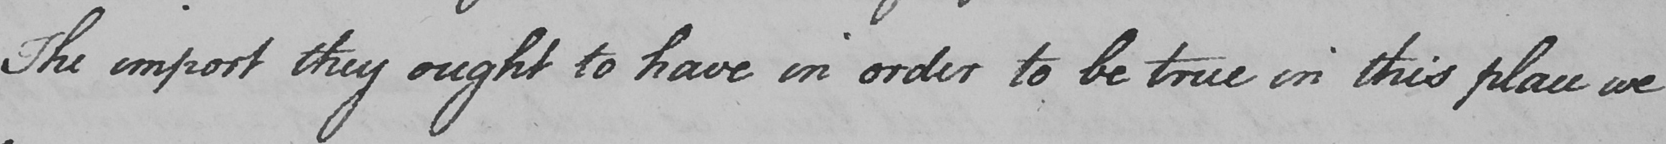Transcribe the text shown in this historical manuscript line. The import they ought to have in order to be true in this place we 